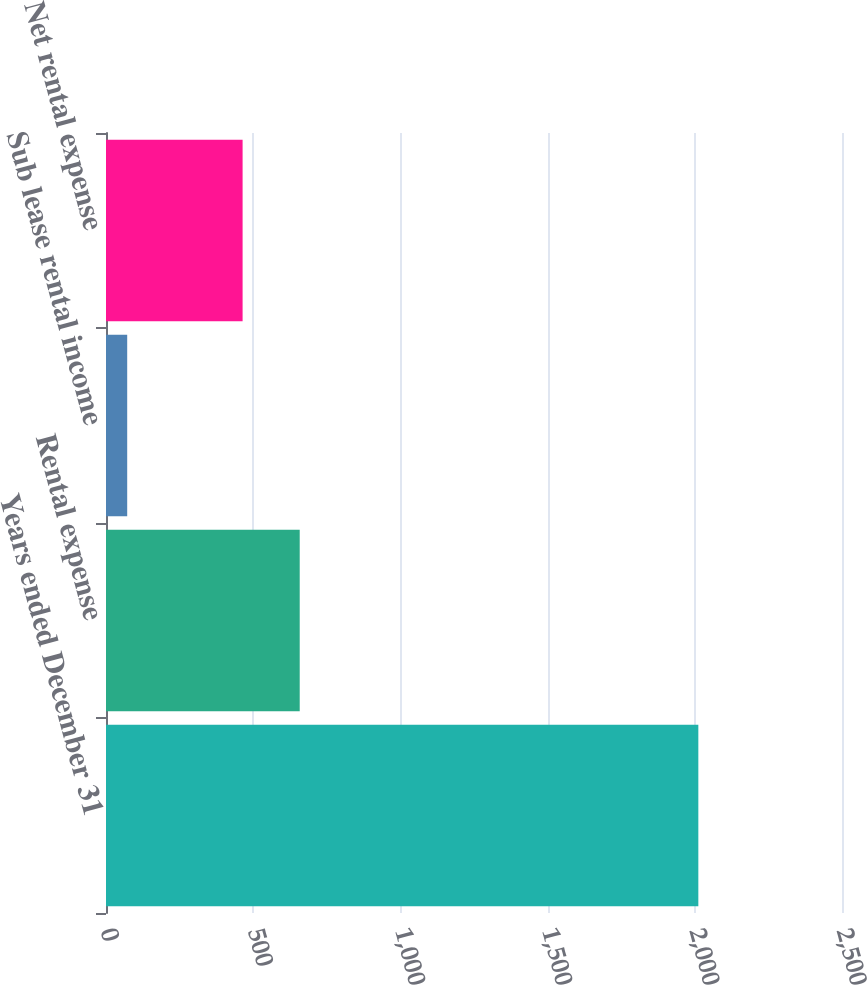Convert chart to OTSL. <chart><loc_0><loc_0><loc_500><loc_500><bar_chart><fcel>Years ended December 31<fcel>Rental expense<fcel>Sub lease rental income<fcel>Net rental expense<nl><fcel>2012<fcel>658<fcel>72<fcel>464<nl></chart> 